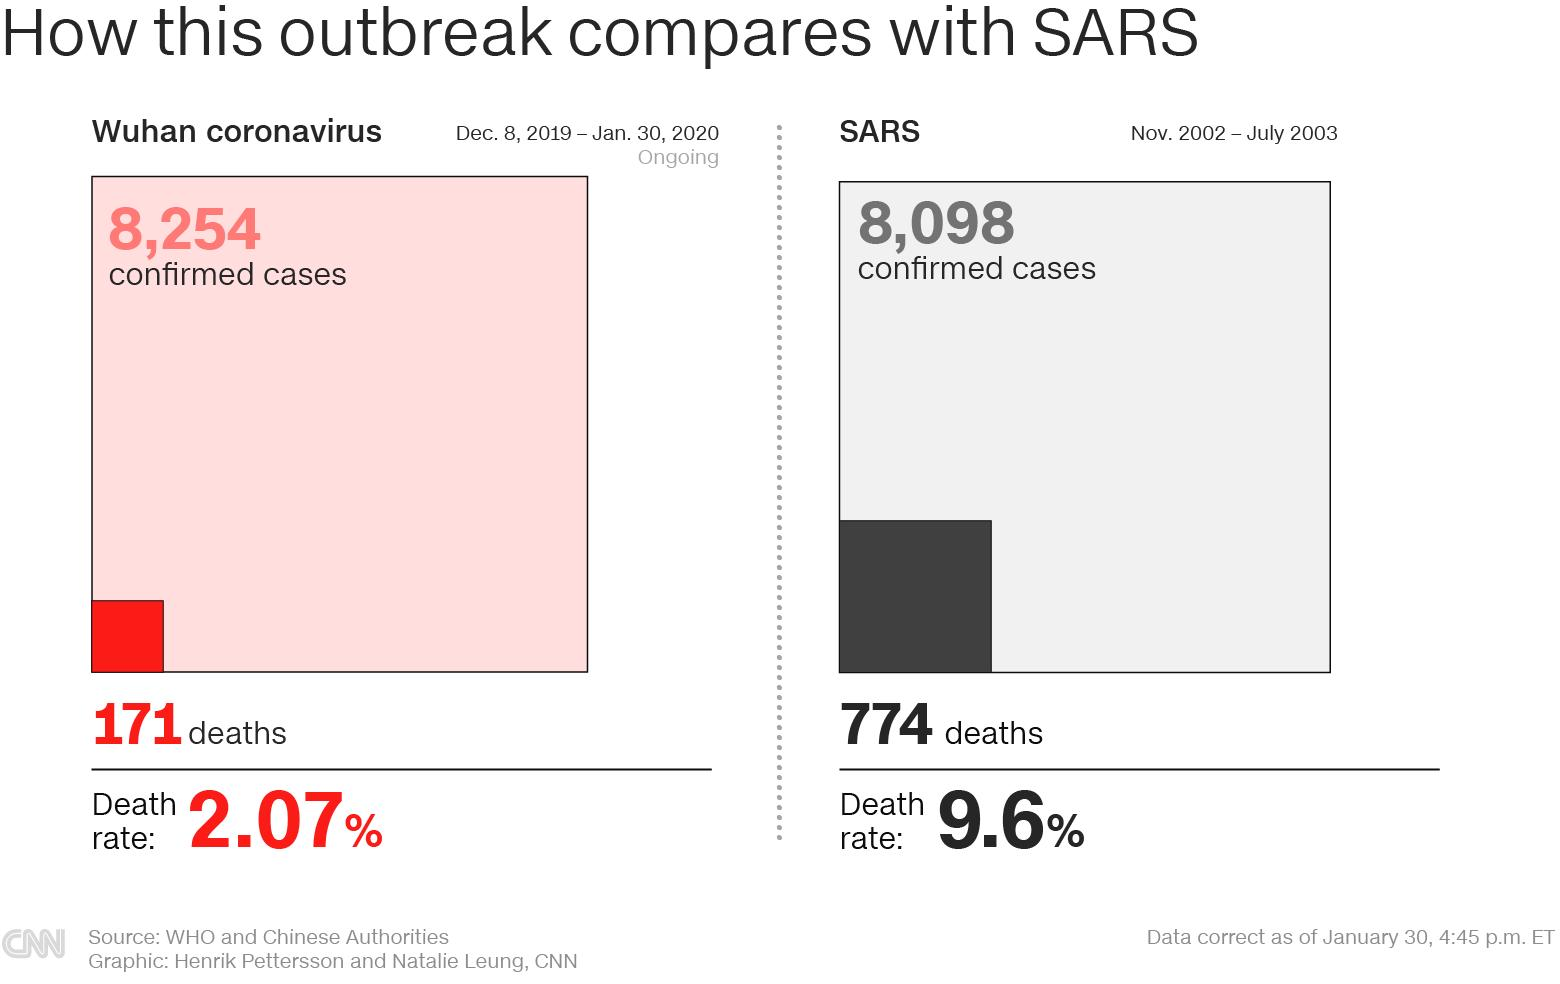Draw attention to some important aspects in this diagram. The COVID-19 outbreak began on December 8, 2019. The SARS virus outbreak occurred during the time period of November 2002 to July 2003. The case fatality rate of COVID-19 is 2.07%. As of January 30th, 2020, the total number of confirmed COVID-19 cases reported in Wuhan, China was 8,254. As of January 30, 2020, a total of 171 deaths due to COVID-19 were reported in China. 